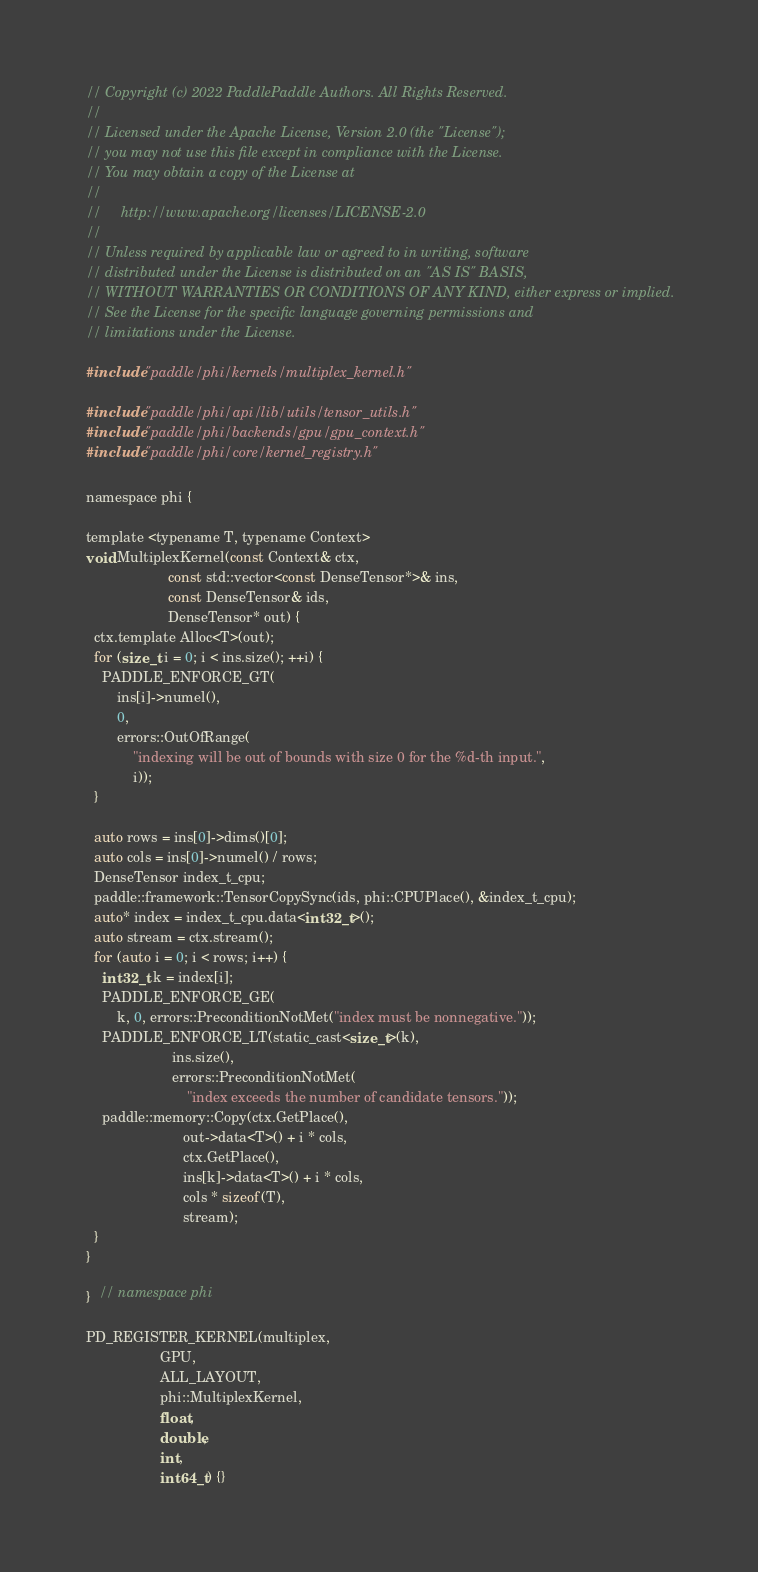Convert code to text. <code><loc_0><loc_0><loc_500><loc_500><_Cuda_>// Copyright (c) 2022 PaddlePaddle Authors. All Rights Reserved.
//
// Licensed under the Apache License, Version 2.0 (the "License");
// you may not use this file except in compliance with the License.
// You may obtain a copy of the License at
//
//     http://www.apache.org/licenses/LICENSE-2.0
//
// Unless required by applicable law or agreed to in writing, software
// distributed under the License is distributed on an "AS IS" BASIS,
// WITHOUT WARRANTIES OR CONDITIONS OF ANY KIND, either express or implied.
// See the License for the specific language governing permissions and
// limitations under the License.

#include "paddle/phi/kernels/multiplex_kernel.h"

#include "paddle/phi/api/lib/utils/tensor_utils.h"
#include "paddle/phi/backends/gpu/gpu_context.h"
#include "paddle/phi/core/kernel_registry.h"

namespace phi {

template <typename T, typename Context>
void MultiplexKernel(const Context& ctx,
                     const std::vector<const DenseTensor*>& ins,
                     const DenseTensor& ids,
                     DenseTensor* out) {
  ctx.template Alloc<T>(out);
  for (size_t i = 0; i < ins.size(); ++i) {
    PADDLE_ENFORCE_GT(
        ins[i]->numel(),
        0,
        errors::OutOfRange(
            "indexing will be out of bounds with size 0 for the %d-th input.",
            i));
  }

  auto rows = ins[0]->dims()[0];
  auto cols = ins[0]->numel() / rows;
  DenseTensor index_t_cpu;
  paddle::framework::TensorCopySync(ids, phi::CPUPlace(), &index_t_cpu);
  auto* index = index_t_cpu.data<int32_t>();
  auto stream = ctx.stream();
  for (auto i = 0; i < rows; i++) {
    int32_t k = index[i];
    PADDLE_ENFORCE_GE(
        k, 0, errors::PreconditionNotMet("index must be nonnegative."));
    PADDLE_ENFORCE_LT(static_cast<size_t>(k),
                      ins.size(),
                      errors::PreconditionNotMet(
                          "index exceeds the number of candidate tensors."));
    paddle::memory::Copy(ctx.GetPlace(),
                         out->data<T>() + i * cols,
                         ctx.GetPlace(),
                         ins[k]->data<T>() + i * cols,
                         cols * sizeof(T),
                         stream);
  }
}

}  // namespace phi

PD_REGISTER_KERNEL(multiplex,
                   GPU,
                   ALL_LAYOUT,
                   phi::MultiplexKernel,
                   float,
                   double,
                   int,
                   int64_t) {}
</code> 